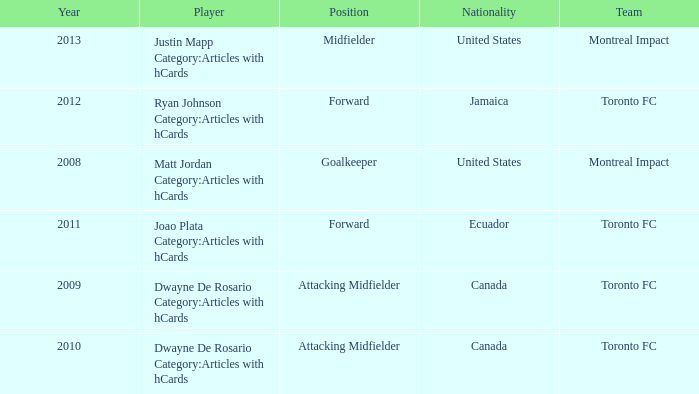What's the nationality of Montreal Impact with Justin Mapp Category:articles with hcards as the player? United States. 